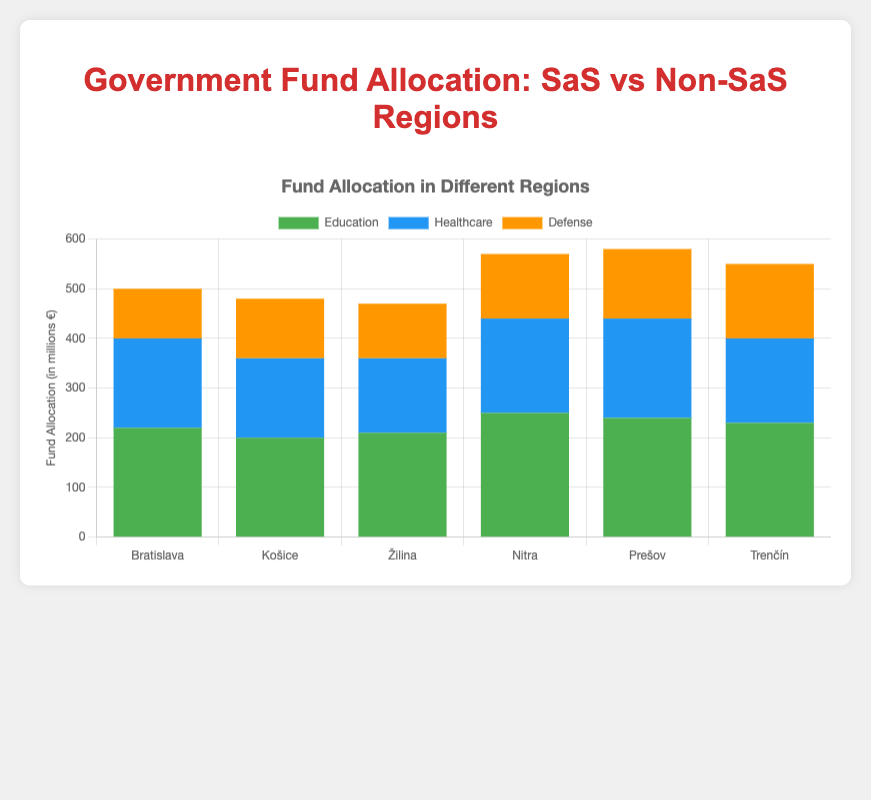What is the total fund allocation to education across all regions? To find the total fund allocation for education, sum up the education funds for each region: Bratislava (220) + Košice (200) + Žilina (210) + Nitra (250) + Prešov (240) + Trenčín (230). 220 + 200 + 210 + 250 + 240 + 230 = 1350.
Answer: 1350 Which region receives the highest total fund allocation? To determine the region with the highest total funding, add up the education, healthcare, and defense funds for each region and compare. Calculation: Bratislava (500), Košice (480), Žilina (470), Nitra (570), Prešov (580), Trenčín (550). Prešov receives the highest total fund allocation at 580.
Answer: Prešov Are SaS-led regions allocating more to healthcare on average than Non-SaS-led regions? Calculate the average healthcare allocation for SaS-led and Non-SaS-led regions. SaS-led: (180 + 160 + 150) / 3 = 490 / 3 ≈ 163.33. Non-SaS-led: (190 + 200 + 170) / 3 = 560 / 3 ≈ 186.67. Non-SaS-led regions allocate more to healthcare on average.
Answer: No Which category, education, healthcare, or defense, has the least total fund allocation in Non-SaS-led regions? Sum up the funds for each category in Non-SaS-led regions: Education: 250 + 240 + 230 = 720, Healthcare: 190 + 200 + 170 = 560, Defense: 130 + 140 + 150 = 420. Defense has the least total allocation.
Answer: Defense How does the defense allocation in SaS-led regions compare to Non-SaS-led regions? Calculate the total defense fund for both affiliations. SaS-led: 100 + 120 + 110 = 330, Non-SaS-led: 130 + 140 + 150 = 420. Non-SaS-led regions allocate more to defense.
Answer: Non-SaS-led regions allocate more Which region has the highest allocation for education? Compare the education allocation values across all regions: Bratislava (220), Košice (200), Žilina (210), Nitra (250), Prešov (240), and Trenčín (230). Nitra has the highest allocation for education with 250.
Answer: Nitra What is the average total fund allocation per region in Non-SaS-led areas? Calculate the total fund allocation for Non-SaS-led regions and find the average. Total for Non-SaS-led regions: Nitra (570), Prešov (580), Trenčín (550). Average = (570 + 580 + 550) / 3 = 1700 / 3 ≈ 566.67.
Answer: 566.67 Is there any region where defense receives the highest portion of its allocation? Compare the allocation amounts within each region to check if defense is the highest in any: Bratislava (100), Košice (120), Žilina (110), Nitra (130), Prešov (140), Trenčín (150). No region allocates the highest fund to defense; education or healthcare always exceeds defense in each region.
Answer: No What is the difference in total fund allocation between Bratislava and Nitra? Calculate the total funds for both regions and take the difference: Bratislava (500), Nitra (570). Difference = 570 - 500 = 70.
Answer: 70 